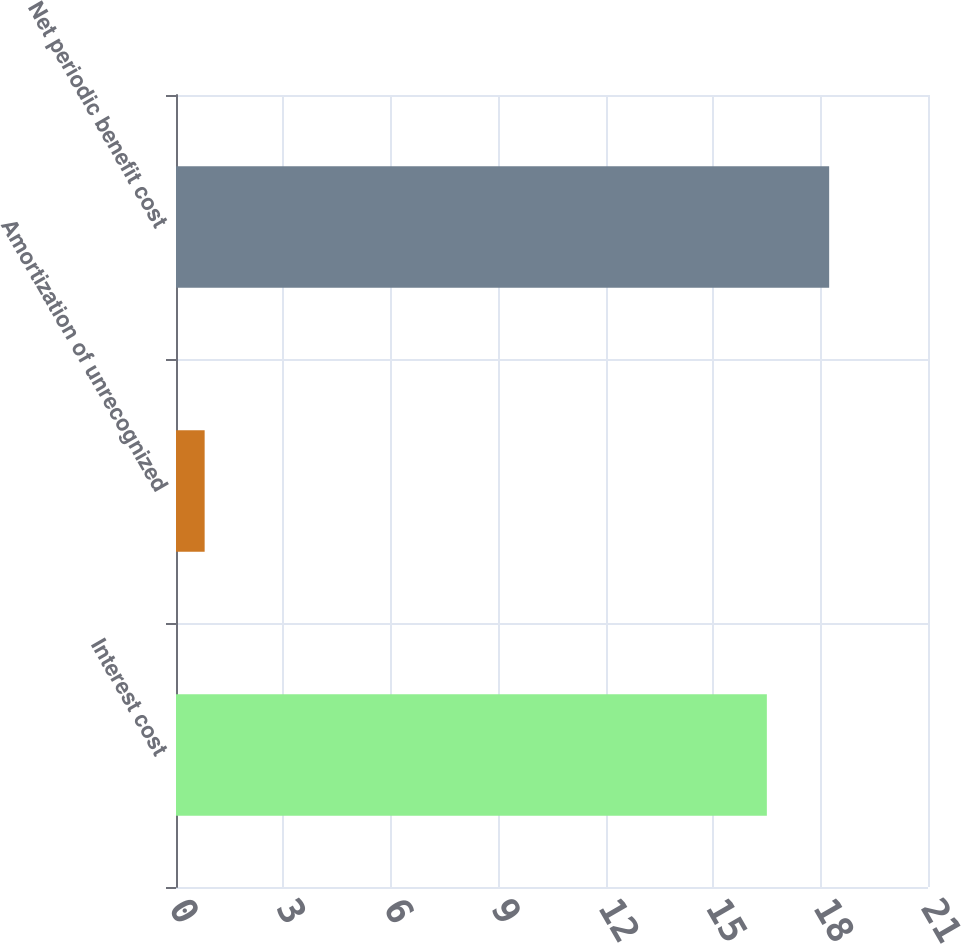<chart> <loc_0><loc_0><loc_500><loc_500><bar_chart><fcel>Interest cost<fcel>Amortization of unrecognized<fcel>Net periodic benefit cost<nl><fcel>16.5<fcel>0.8<fcel>18.24<nl></chart> 